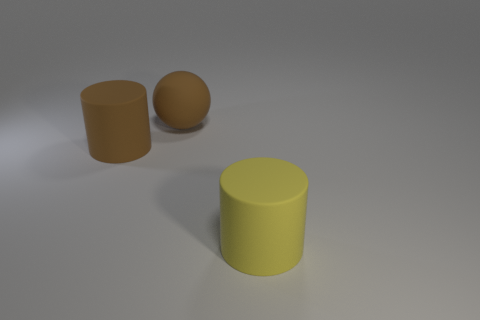How many things are either rubber cylinders that are on the left side of the big brown ball or rubber things?
Your response must be concise. 3. What number of objects are either big cyan cubes or big rubber cylinders that are to the right of the brown cylinder?
Provide a succinct answer. 1. There is a large yellow rubber object to the right of the big brown matte object right of the big brown cylinder; how many brown rubber things are behind it?
Make the answer very short. 2. There is a sphere that is the same size as the yellow matte cylinder; what is its material?
Offer a very short reply. Rubber. Are there any yellow rubber things of the same size as the sphere?
Give a very brief answer. Yes. The big rubber ball has what color?
Ensure brevity in your answer.  Brown. There is a large object right of the ball behind the yellow matte cylinder; what color is it?
Offer a very short reply. Yellow. There is a big object that is to the right of the brown thing that is behind the big cylinder that is on the left side of the yellow thing; what is its shape?
Your answer should be compact. Cylinder. How many other brown spheres are the same material as the brown ball?
Give a very brief answer. 0. There is a big matte cylinder behind the large yellow object; how many yellow matte cylinders are in front of it?
Give a very brief answer. 1. 